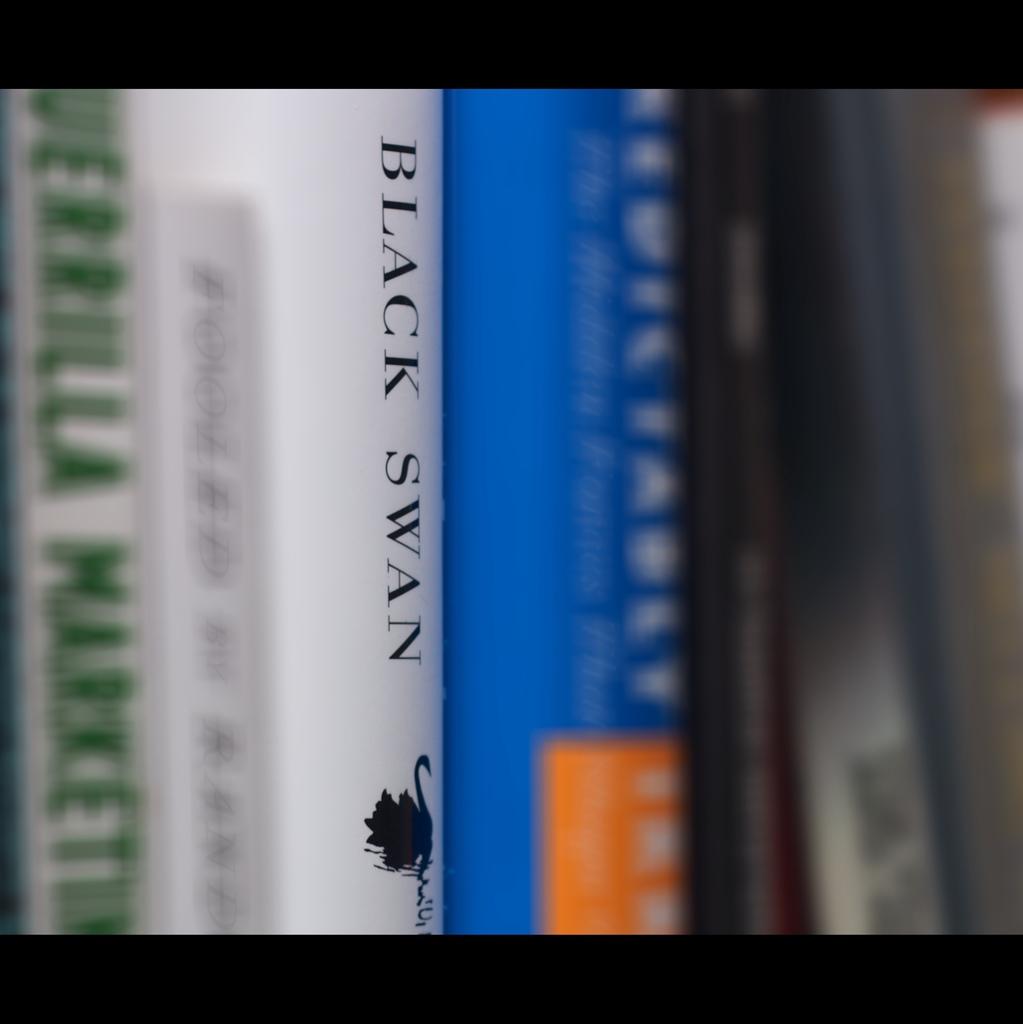What is the large black bird referenced by this book title?
Provide a short and direct response. Swan. What is black?
Provide a succinct answer. Swan. 